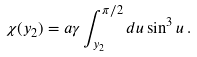<formula> <loc_0><loc_0><loc_500><loc_500>\chi ( y _ { 2 } ) = a \gamma \int _ { y _ { 2 } } ^ { \pi / 2 } d u \sin ^ { 3 } u \, .</formula> 